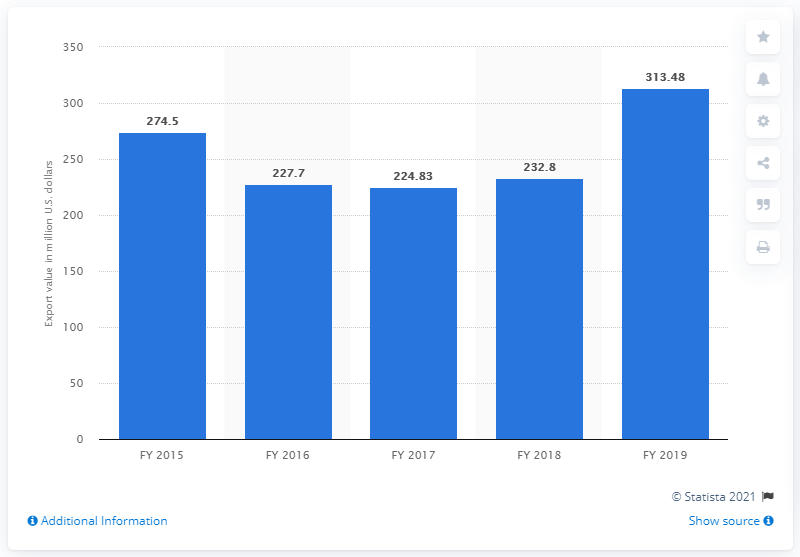Draw attention to some important aspects in this diagram. The previous year's export value of sports goods was 232.8 million dollars. In the fiscal year of 2019, the export value of sports goods was 313.48 million. 